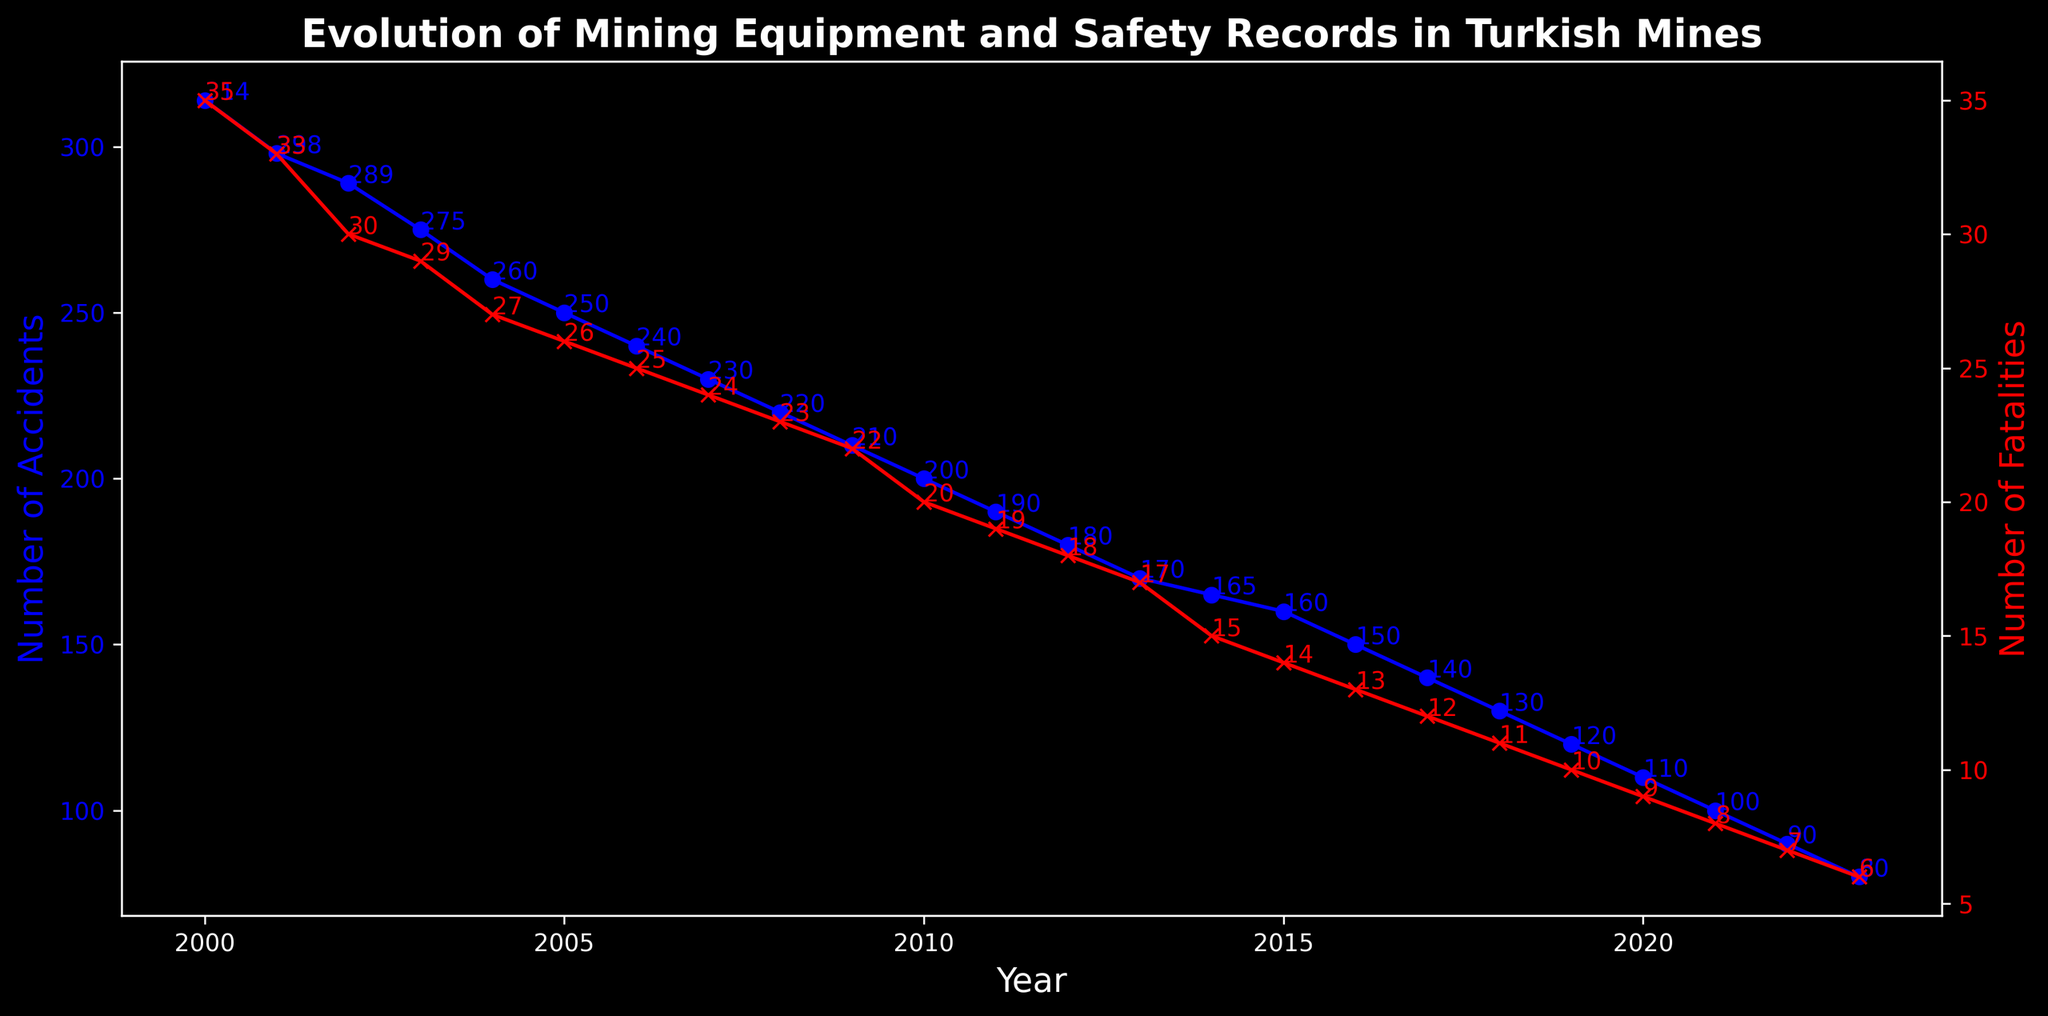What trends can be observed in the number of accidents and fatalities over the years? The graph shows a steady decline in both the number of accidents and fatalities from 2000 to 2023. This can be observed as both lines decrease over the years. Specifically, the number of accidents decreases from 314 in 2000 to 80 in 2023, while fatalities decrease from 35 in 2000 to 6 in 2023. This indicates an overall improvement in safety conditions over time.
Answer: Accidents and fatalities both show a steady decline How did the introduction of Early Mechanical technologies in 2006 affect the number of accidents and fatalities? By observing the plot, we see that with the introduction of Early Mechanical technologies in 2006, the number of accidents and fatalities continues to decrease. Accidents reduce from 250 to 240 between 2005 and 2006, while fatalities drop from 26 to 25. This suggests that Early Mechanical technologies may have had a positive impact on safety.
Answer: Reduced slightly What is the combined total number of accidents in the years 2010 and 2020? To find the combined total number of accidents in 2010 and 2020, add the number of accidents in each of these years. From the chart, in 2010 there were 200 accidents, and in 2020 there were 110 accidents. So, 200 + 110 = 310.
Answer: 310 Which year observed the highest number of fatalities, and what was the number? By inspecting the red line representing fatalities, the highest point is in the year 2000 with 35 fatalities.
Answer: 2000, 35 What significant change can be seen after the year 2015 in terms of mining technology and its impact on safety records? After the year 2015, the graph shows a more pronounced decline in both accidents and fatalities. This period marks the use of Advanced Mechanical technologies. The number of accidents decreased from 165 in 2014 to 160 in 2015, while fatalities decreased from 15 to 14. The trend continues downward, suggesting noticeable improvements in safety.
Answer: Significant decline How does the number of fatalities in 2023 compare to the number in 2020? In 2023, the number of fatalities is 6, while in 2020 it is 9. Comparing these, 6 is less than 9, indicating a decrease in fatalities over these three years.
Answer: Decreased What technology period corresponds to the year with the lowest number of accidents, and how many accidents were there? The lowest number of accidents is 80, observed in the year 2023, which corresponds to the period of Digital Technologies.
Answer: Digital Technologies, 80 Calculate the average number of accidents for the period of Modern Mechanical technologies (2010-2014). Sum the number of accidents during 2010-2014 and divide by the number of years. The number of accidents are: 200 (2010), 190 (2011), 180 (2012), 170 (2013), 165 (2014). Sum = 200 + 190 + 180 + 170 + 165 = 905. The number of years is 5. So, the average is 905/5 = 181.
Answer: 181 Which mining technology correctly aligns with the introduction of the largest decreases in fatalities? Observing the red line, the most significant decreases in fatalities occur during the period of Digital Technologies, starting in 2020.
Answer: Digital Technologies Between 2000 and 2023, which year observed the most significant single-year decrease in the number of accidents? By examining the blue line for the steepest drop, the year 2021 to 2022 shows the most significant decrease in the number of accidents, from 100 to 90. This is a drop of 10 accidents.
Answer: 2021 to 2022, 10 